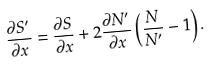<formula> <loc_0><loc_0><loc_500><loc_500>\frac { \partial S ^ { \prime } } { \partial x } = \frac { \partial S } { \partial x } + 2 \frac { \partial N ^ { \prime } } { \partial x } \left ( \frac { N } { N ^ { \prime } } - 1 \right ) .</formula> 